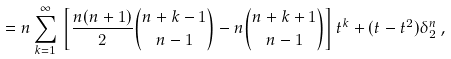Convert formula to latex. <formula><loc_0><loc_0><loc_500><loc_500>= n \sum _ { k = 1 } ^ { \infty } \, \left [ \frac { n ( n + 1 ) } { 2 } { n + k - 1 \choose n - 1 } - n { n + k + 1 \choose n - 1 } \right ] t ^ { k } + ( t - t ^ { 2 } ) \delta _ { 2 } ^ { n } \, ,</formula> 